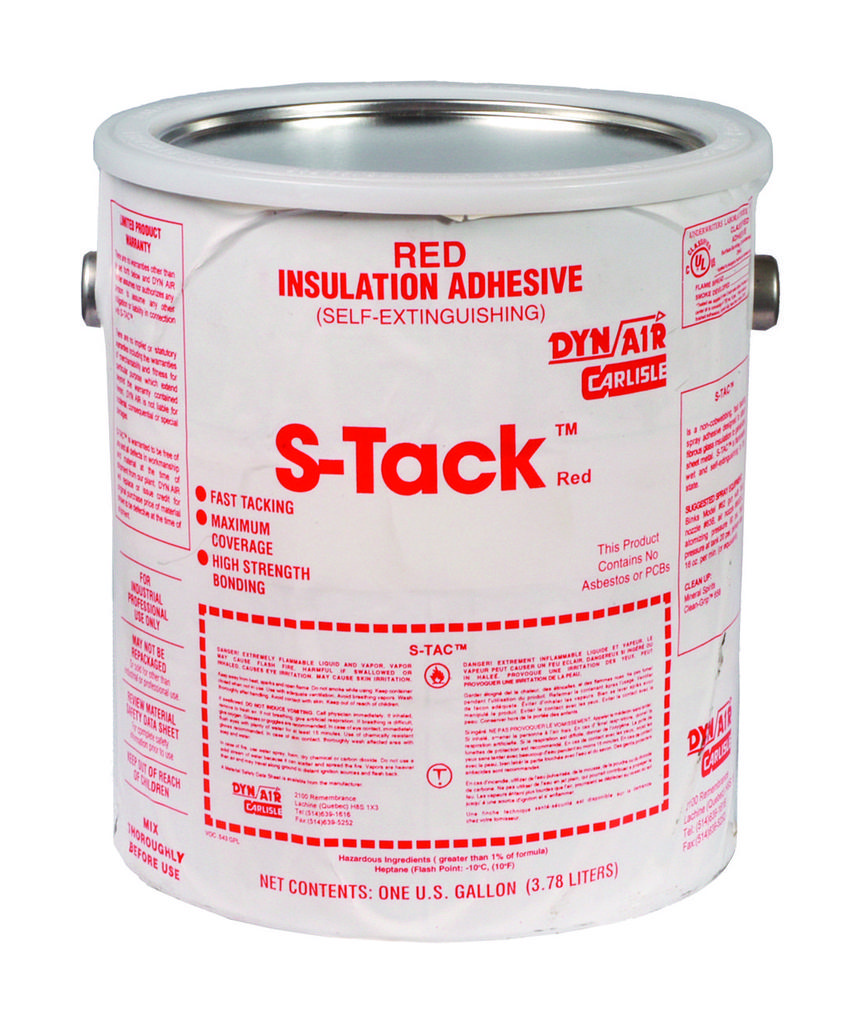What color is the insulation adhesive?
Provide a succinct answer. Red. What is the name of this product?
Provide a succinct answer. S-tack. 